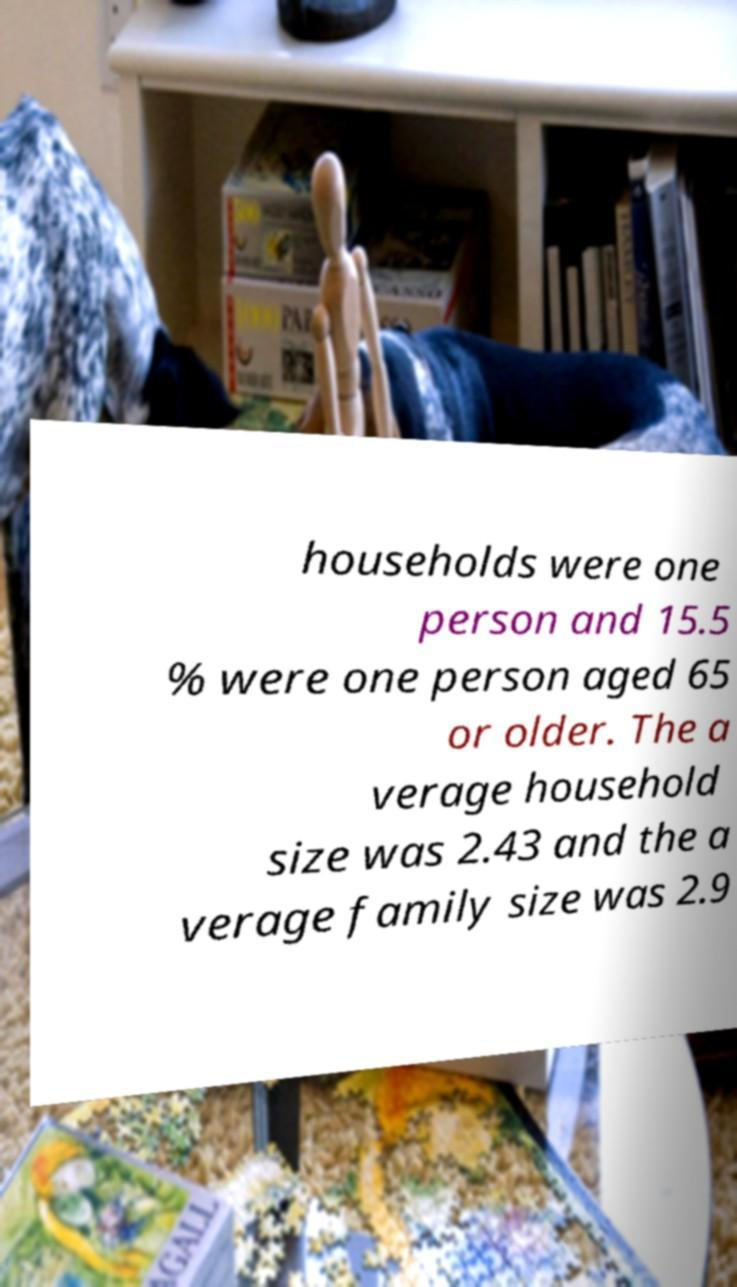There's text embedded in this image that I need extracted. Can you transcribe it verbatim? households were one person and 15.5 % were one person aged 65 or older. The a verage household size was 2.43 and the a verage family size was 2.9 